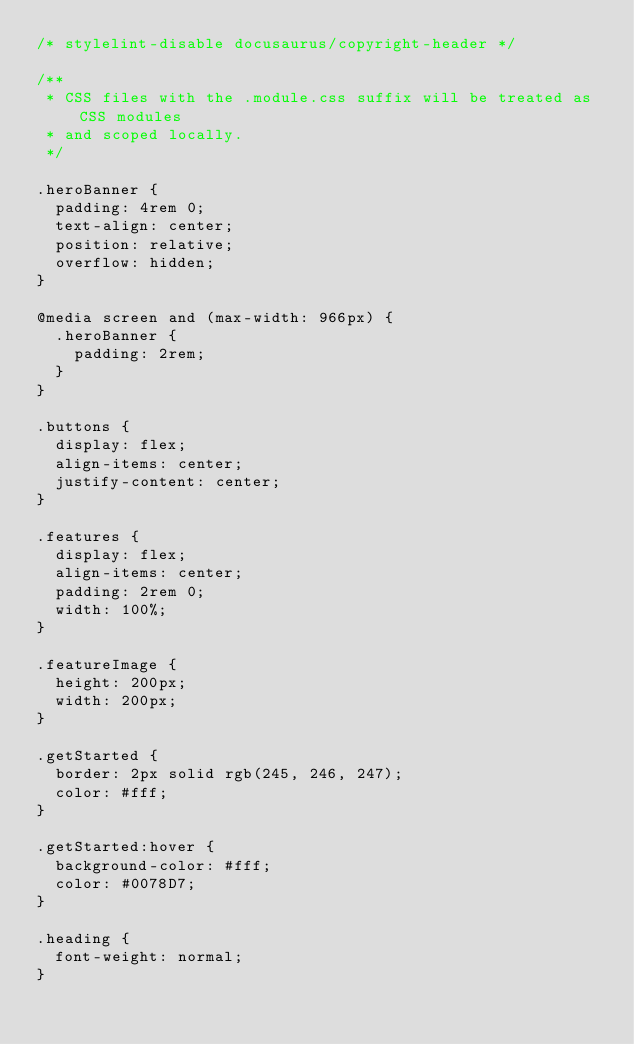<code> <loc_0><loc_0><loc_500><loc_500><_CSS_>/* stylelint-disable docusaurus/copyright-header */

/**
 * CSS files with the .module.css suffix will be treated as CSS modules
 * and scoped locally.
 */

.heroBanner {
  padding: 4rem 0;
  text-align: center;
  position: relative;
  overflow: hidden;
}

@media screen and (max-width: 966px) {
  .heroBanner {
    padding: 2rem;
  }
}

.buttons {
  display: flex;
  align-items: center;
  justify-content: center;
}

.features {
  display: flex;
  align-items: center;
  padding: 2rem 0;
  width: 100%;
}

.featureImage {
  height: 200px;
  width: 200px;
}

.getStarted {  
  border: 2px solid rgb(245, 246, 247);
  color: #fff;      
}

.getStarted:hover {
  background-color: #fff;
  color: #0078D7;
}

.heading {
  font-weight: normal;
}
</code> 